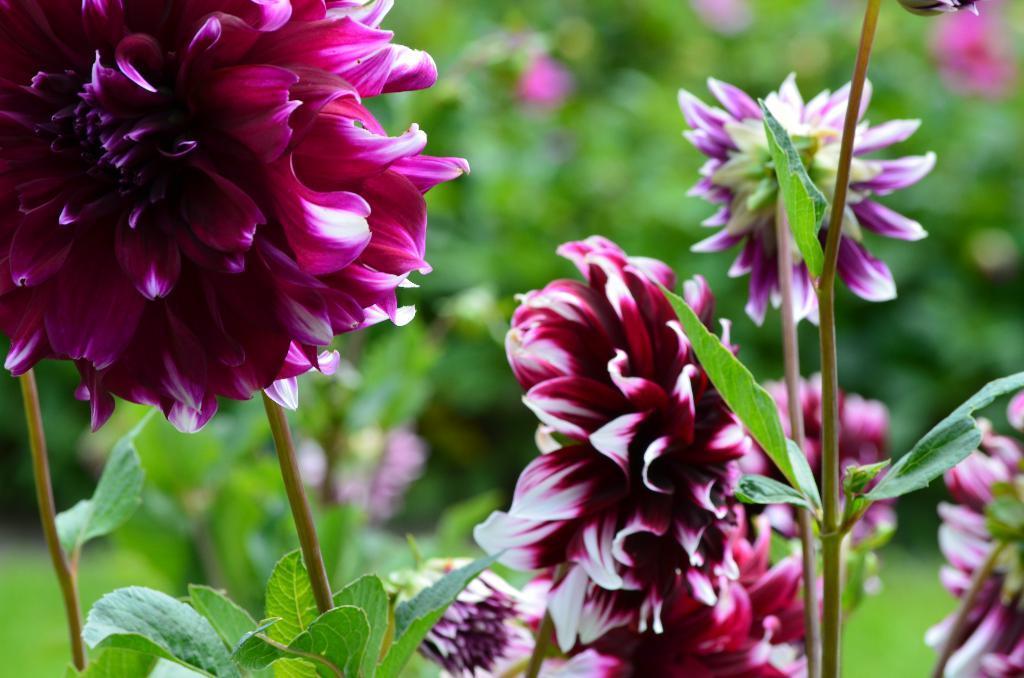Can you describe this image briefly? In this picture, we can see plants, flowers, and the blurred background. 